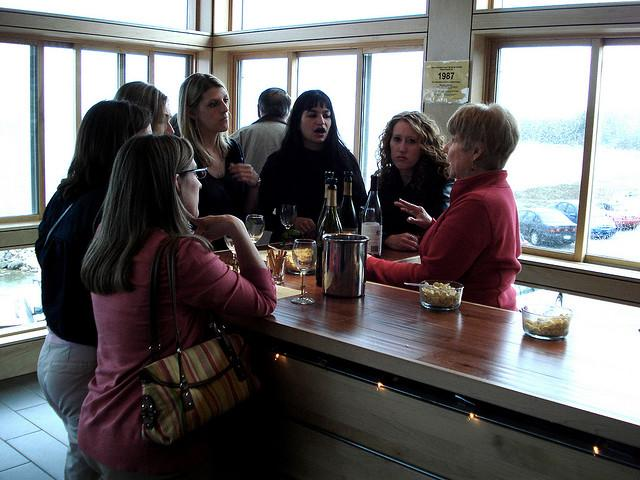What do the ladies here discuss?

Choices:
A) anteaters
B) wine
C) women
D) retirement wine 